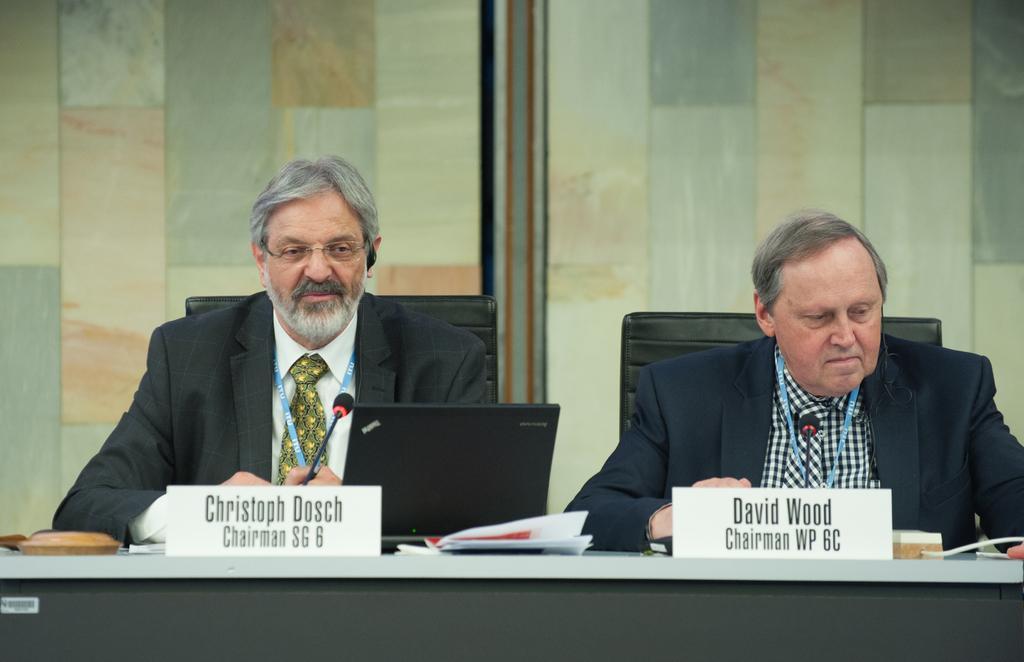Can you describe this image briefly? In this image I can see two persons sitting, the person at right is wearing blue color blazer and, black and white shirt and the person at left is wearing black blazer, white shirt. In front I can see two microphones, a laptop, few papers on the table and I can see gray and brown color background. 